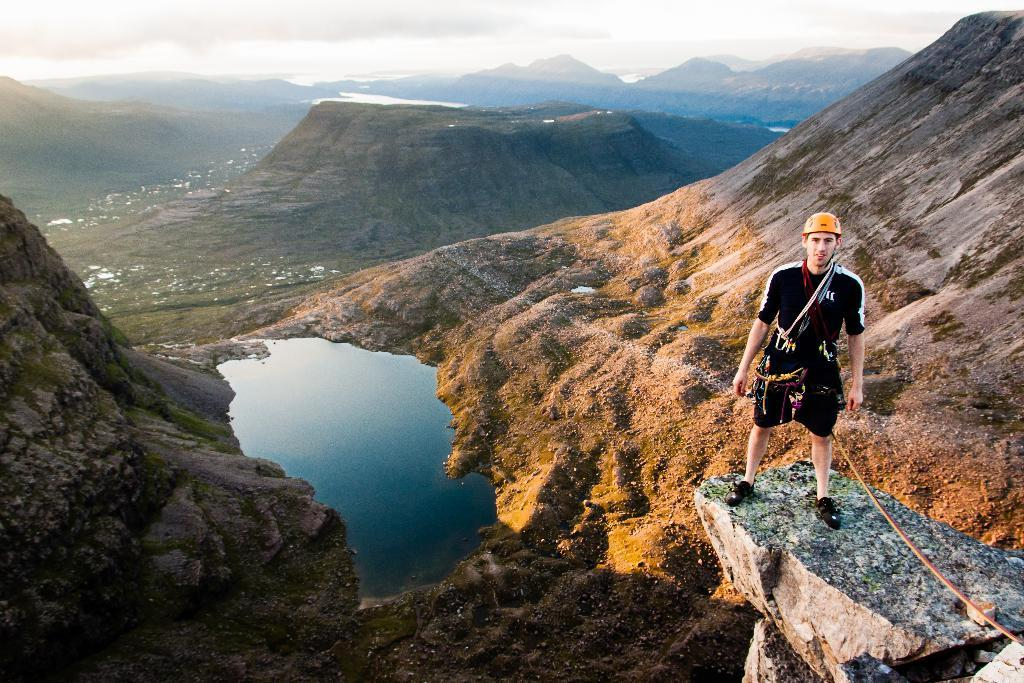What type of landscape is depicted in the image? There are hills in the image. What else can be seen in the image besides the hills? There is water and a person wearing a helmet in the image. What is the person wearing in the image? The person is wearing a black dress. What is visible at the top of the image? The sky is visible at the top of the image. Where can the honey be found in the image? There is no honey present in the image. What type of yam is being harvested by the person in the image? There is no yam or harvesting activity depicted in the image. 